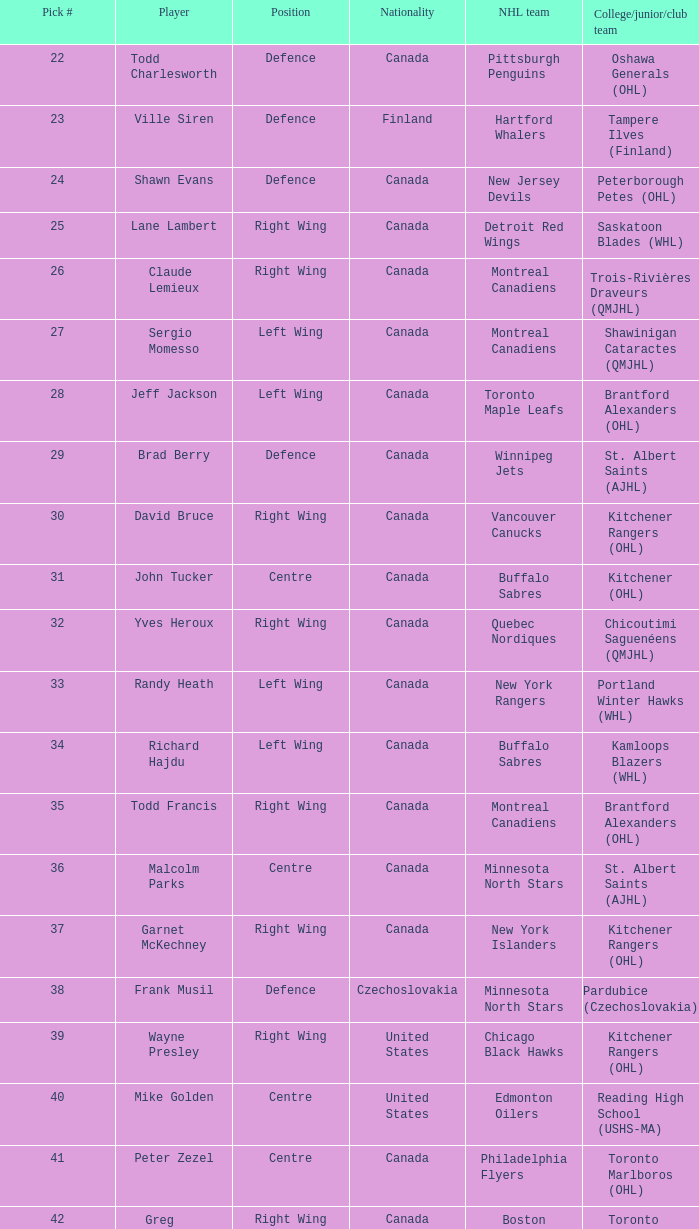Write the full table. {'header': ['Pick #', 'Player', 'Position', 'Nationality', 'NHL team', 'College/junior/club team'], 'rows': [['22', 'Todd Charlesworth', 'Defence', 'Canada', 'Pittsburgh Penguins', 'Oshawa Generals (OHL)'], ['23', 'Ville Siren', 'Defence', 'Finland', 'Hartford Whalers', 'Tampere Ilves (Finland)'], ['24', 'Shawn Evans', 'Defence', 'Canada', 'New Jersey Devils', 'Peterborough Petes (OHL)'], ['25', 'Lane Lambert', 'Right Wing', 'Canada', 'Detroit Red Wings', 'Saskatoon Blades (WHL)'], ['26', 'Claude Lemieux', 'Right Wing', 'Canada', 'Montreal Canadiens', 'Trois-Rivières Draveurs (QMJHL)'], ['27', 'Sergio Momesso', 'Left Wing', 'Canada', 'Montreal Canadiens', 'Shawinigan Cataractes (QMJHL)'], ['28', 'Jeff Jackson', 'Left Wing', 'Canada', 'Toronto Maple Leafs', 'Brantford Alexanders (OHL)'], ['29', 'Brad Berry', 'Defence', 'Canada', 'Winnipeg Jets', 'St. Albert Saints (AJHL)'], ['30', 'David Bruce', 'Right Wing', 'Canada', 'Vancouver Canucks', 'Kitchener Rangers (OHL)'], ['31', 'John Tucker', 'Centre', 'Canada', 'Buffalo Sabres', 'Kitchener (OHL)'], ['32', 'Yves Heroux', 'Right Wing', 'Canada', 'Quebec Nordiques', 'Chicoutimi Saguenéens (QMJHL)'], ['33', 'Randy Heath', 'Left Wing', 'Canada', 'New York Rangers', 'Portland Winter Hawks (WHL)'], ['34', 'Richard Hajdu', 'Left Wing', 'Canada', 'Buffalo Sabres', 'Kamloops Blazers (WHL)'], ['35', 'Todd Francis', 'Right Wing', 'Canada', 'Montreal Canadiens', 'Brantford Alexanders (OHL)'], ['36', 'Malcolm Parks', 'Centre', 'Canada', 'Minnesota North Stars', 'St. Albert Saints (AJHL)'], ['37', 'Garnet McKechney', 'Right Wing', 'Canada', 'New York Islanders', 'Kitchener Rangers (OHL)'], ['38', 'Frank Musil', 'Defence', 'Czechoslovakia', 'Minnesota North Stars', 'Pardubice (Czechoslovakia)'], ['39', 'Wayne Presley', 'Right Wing', 'United States', 'Chicago Black Hawks', 'Kitchener Rangers (OHL)'], ['40', 'Mike Golden', 'Centre', 'United States', 'Edmonton Oilers', 'Reading High School (USHS-MA)'], ['41', 'Peter Zezel', 'Centre', 'Canada', 'Philadelphia Flyers', 'Toronto Marlboros (OHL)'], ['42', 'Greg Johnston', 'Right Wing', 'Canada', 'Boston Bruins', 'Toronto Marlboros (OHL)']]} What is the nationality of the player named randy heath? Canada. 